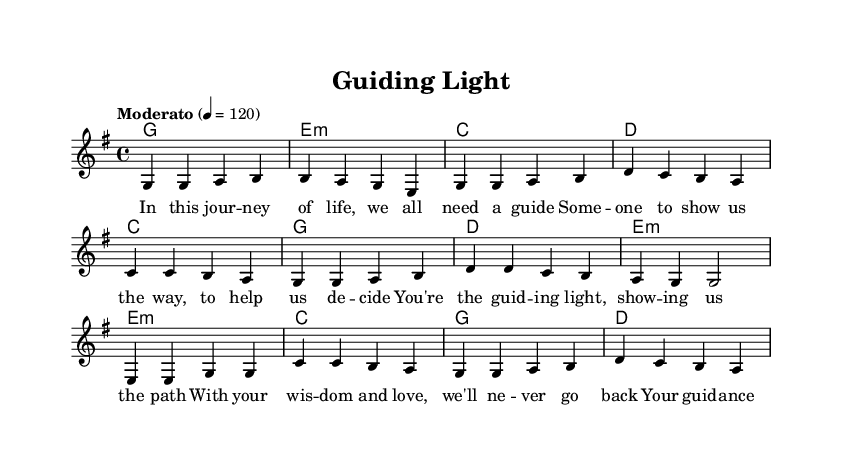What is the key signature of this music? The key signature is G major, which has one sharp (F#).
Answer: G major What is the time signature of this music? The time signature is 4/4, indicating four beats per measure.
Answer: 4/4 What is the tempo marking in this piece? The tempo marking is "Moderato," indicating a moderate speed, typically around 108-120 beats per minute.
Answer: Moderato How many measures are in the chorus section? The chorus section consists of four measures, as indicated by the four sets of music notation.
Answer: Four What is the main theme of the lyrics in this song? The main theme of the lyrics is guidance and mentorship, emphasizing the importance of having someone to show the way in life.
Answer: Guidance and mentorship What musical form does this piece follow? The piece follows a verse-chorus-bridge structure, commonly found in many songs, highlighting the flow from themes to a climax and resolution.
Answer: Verse-chorus-bridge What is the emotional tone conveyed in the lyrics of the bridge? The emotional tone of the bridge conveys strength and support, focusing on love and guidance, which is essential for personal growth.
Answer: Strength and support 